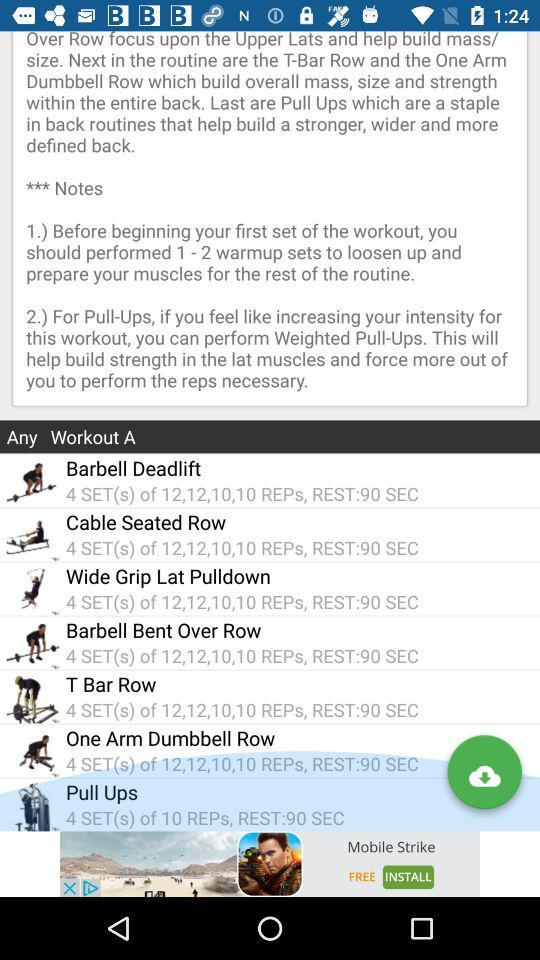How many sets are there in "T Bar Row"? There are 4 sets. 